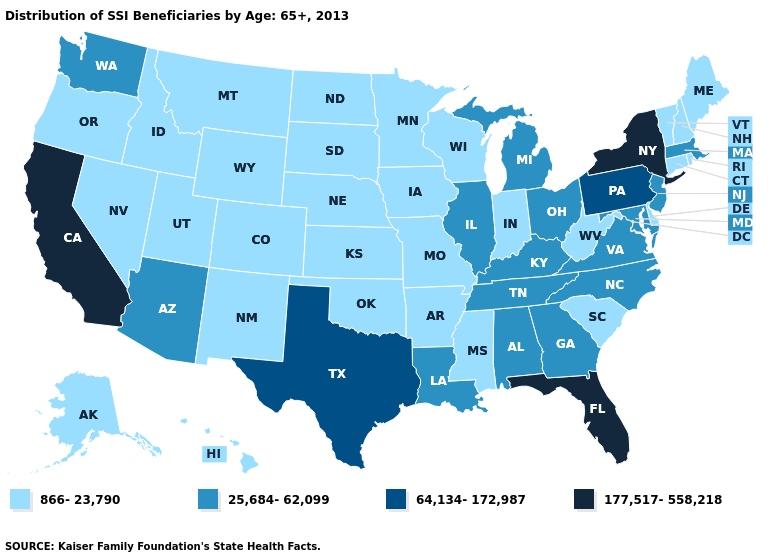Does the map have missing data?
Be succinct. No. What is the highest value in the USA?
Concise answer only. 177,517-558,218. Does Pennsylvania have the lowest value in the USA?
Short answer required. No. Which states hav the highest value in the West?
Quick response, please. California. What is the value of Georgia?
Quick response, please. 25,684-62,099. Does Indiana have a higher value than Nebraska?
Answer briefly. No. Among the states that border Connecticut , does Rhode Island have the highest value?
Short answer required. No. Does the map have missing data?
Keep it brief. No. Name the states that have a value in the range 64,134-172,987?
Answer briefly. Pennsylvania, Texas. Does Mississippi have a lower value than Michigan?
Write a very short answer. Yes. What is the value of Idaho?
Concise answer only. 866-23,790. Name the states that have a value in the range 866-23,790?
Write a very short answer. Alaska, Arkansas, Colorado, Connecticut, Delaware, Hawaii, Idaho, Indiana, Iowa, Kansas, Maine, Minnesota, Mississippi, Missouri, Montana, Nebraska, Nevada, New Hampshire, New Mexico, North Dakota, Oklahoma, Oregon, Rhode Island, South Carolina, South Dakota, Utah, Vermont, West Virginia, Wisconsin, Wyoming. What is the value of Minnesota?
Keep it brief. 866-23,790. What is the value of Oklahoma?
Be succinct. 866-23,790. 